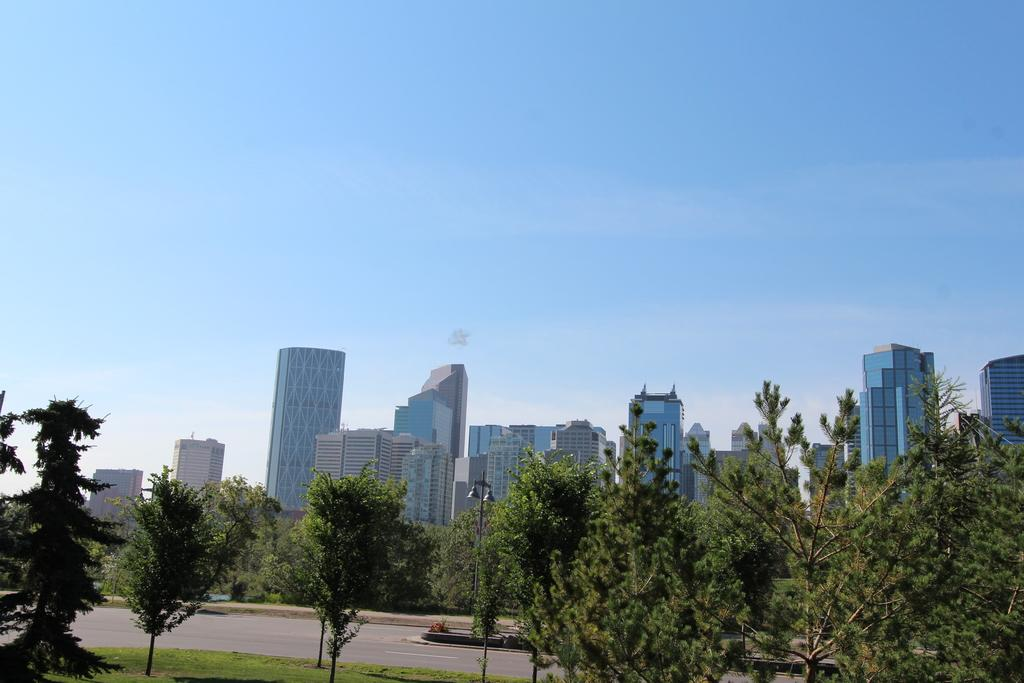What can be seen in the image that provides illumination? There are lights in the image. What structure is present in the image that supports the lights? There is a pole in the image. What type of natural environment is visible in the image? There is grass in the image. What type of man-made structure is visible in the image? There is a road in the image. What type of vegetation is visible in the image? There are trees in the image. What can be seen in the background of the image? There are buildings and sky visible in the background of the image. Can you tell me where the train is located in the image? There is no train present in the image. What type of food is being served for lunch in the image? There is no mention of lunch or any food in the image. 